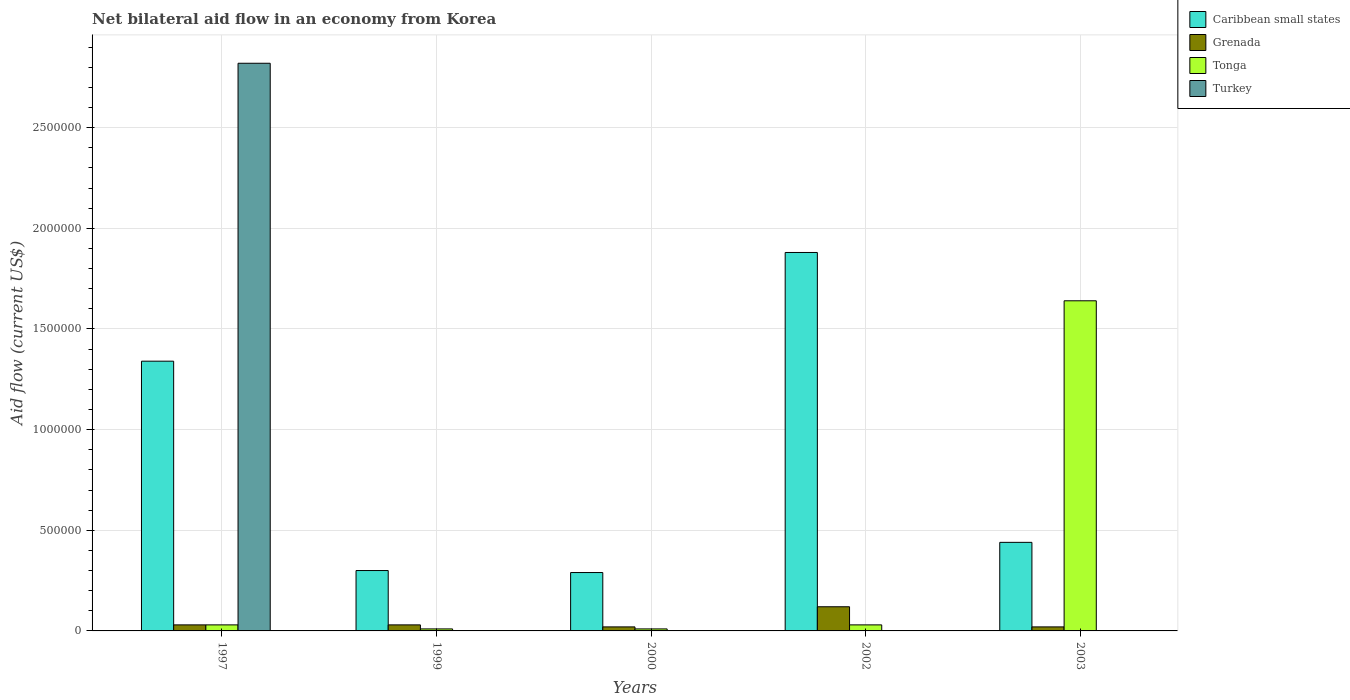How many different coloured bars are there?
Your answer should be very brief. 4. How many groups of bars are there?
Provide a short and direct response. 5. Are the number of bars on each tick of the X-axis equal?
Provide a succinct answer. No. How many bars are there on the 5th tick from the right?
Your answer should be very brief. 4. What is the label of the 1st group of bars from the left?
Give a very brief answer. 1997. In how many cases, is the number of bars for a given year not equal to the number of legend labels?
Offer a terse response. 4. Across all years, what is the minimum net bilateral aid flow in Caribbean small states?
Give a very brief answer. 2.90e+05. In which year was the net bilateral aid flow in Turkey maximum?
Provide a succinct answer. 1997. What is the difference between the net bilateral aid flow in Caribbean small states in 2003 and the net bilateral aid flow in Turkey in 1997?
Your response must be concise. -2.38e+06. What is the average net bilateral aid flow in Turkey per year?
Your response must be concise. 5.64e+05. In the year 2003, what is the difference between the net bilateral aid flow in Grenada and net bilateral aid flow in Tonga?
Your response must be concise. -1.62e+06. In how many years, is the net bilateral aid flow in Turkey greater than 2500000 US$?
Your answer should be compact. 1. What is the ratio of the net bilateral aid flow in Grenada in 1997 to that in 2000?
Ensure brevity in your answer.  1.5. Is the net bilateral aid flow in Tonga in 1999 less than that in 2000?
Provide a succinct answer. No. What is the difference between the highest and the second highest net bilateral aid flow in Grenada?
Offer a terse response. 9.00e+04. What is the difference between the highest and the lowest net bilateral aid flow in Grenada?
Give a very brief answer. 1.00e+05. In how many years, is the net bilateral aid flow in Turkey greater than the average net bilateral aid flow in Turkey taken over all years?
Keep it short and to the point. 1. Is it the case that in every year, the sum of the net bilateral aid flow in Turkey and net bilateral aid flow in Tonga is greater than the sum of net bilateral aid flow in Caribbean small states and net bilateral aid flow in Grenada?
Offer a terse response. No. What is the difference between two consecutive major ticks on the Y-axis?
Ensure brevity in your answer.  5.00e+05. Does the graph contain any zero values?
Offer a terse response. Yes. How many legend labels are there?
Provide a succinct answer. 4. What is the title of the graph?
Offer a very short reply. Net bilateral aid flow in an economy from Korea. What is the label or title of the X-axis?
Your answer should be compact. Years. What is the label or title of the Y-axis?
Provide a short and direct response. Aid flow (current US$). What is the Aid flow (current US$) in Caribbean small states in 1997?
Your answer should be very brief. 1.34e+06. What is the Aid flow (current US$) of Turkey in 1997?
Give a very brief answer. 2.82e+06. What is the Aid flow (current US$) of Caribbean small states in 1999?
Ensure brevity in your answer.  3.00e+05. What is the Aid flow (current US$) in Tonga in 1999?
Offer a very short reply. 10000. What is the Aid flow (current US$) of Caribbean small states in 2000?
Keep it short and to the point. 2.90e+05. What is the Aid flow (current US$) in Turkey in 2000?
Keep it short and to the point. 0. What is the Aid flow (current US$) of Caribbean small states in 2002?
Provide a succinct answer. 1.88e+06. What is the Aid flow (current US$) of Caribbean small states in 2003?
Offer a terse response. 4.40e+05. What is the Aid flow (current US$) in Tonga in 2003?
Your response must be concise. 1.64e+06. What is the Aid flow (current US$) in Turkey in 2003?
Offer a very short reply. 0. Across all years, what is the maximum Aid flow (current US$) of Caribbean small states?
Offer a very short reply. 1.88e+06. Across all years, what is the maximum Aid flow (current US$) of Grenada?
Ensure brevity in your answer.  1.20e+05. Across all years, what is the maximum Aid flow (current US$) in Tonga?
Give a very brief answer. 1.64e+06. Across all years, what is the maximum Aid flow (current US$) in Turkey?
Your answer should be very brief. 2.82e+06. Across all years, what is the minimum Aid flow (current US$) of Turkey?
Your answer should be very brief. 0. What is the total Aid flow (current US$) of Caribbean small states in the graph?
Give a very brief answer. 4.25e+06. What is the total Aid flow (current US$) in Tonga in the graph?
Give a very brief answer. 1.72e+06. What is the total Aid flow (current US$) of Turkey in the graph?
Offer a very short reply. 2.82e+06. What is the difference between the Aid flow (current US$) in Caribbean small states in 1997 and that in 1999?
Ensure brevity in your answer.  1.04e+06. What is the difference between the Aid flow (current US$) in Grenada in 1997 and that in 1999?
Your answer should be very brief. 0. What is the difference between the Aid flow (current US$) in Tonga in 1997 and that in 1999?
Make the answer very short. 2.00e+04. What is the difference between the Aid flow (current US$) in Caribbean small states in 1997 and that in 2000?
Your response must be concise. 1.05e+06. What is the difference between the Aid flow (current US$) in Caribbean small states in 1997 and that in 2002?
Ensure brevity in your answer.  -5.40e+05. What is the difference between the Aid flow (current US$) in Grenada in 1997 and that in 2002?
Offer a terse response. -9.00e+04. What is the difference between the Aid flow (current US$) in Tonga in 1997 and that in 2002?
Provide a succinct answer. 0. What is the difference between the Aid flow (current US$) of Grenada in 1997 and that in 2003?
Provide a succinct answer. 10000. What is the difference between the Aid flow (current US$) in Tonga in 1997 and that in 2003?
Your response must be concise. -1.61e+06. What is the difference between the Aid flow (current US$) of Caribbean small states in 1999 and that in 2000?
Offer a very short reply. 10000. What is the difference between the Aid flow (current US$) in Tonga in 1999 and that in 2000?
Your response must be concise. 0. What is the difference between the Aid flow (current US$) of Caribbean small states in 1999 and that in 2002?
Offer a very short reply. -1.58e+06. What is the difference between the Aid flow (current US$) in Caribbean small states in 1999 and that in 2003?
Ensure brevity in your answer.  -1.40e+05. What is the difference between the Aid flow (current US$) in Tonga in 1999 and that in 2003?
Keep it short and to the point. -1.63e+06. What is the difference between the Aid flow (current US$) of Caribbean small states in 2000 and that in 2002?
Keep it short and to the point. -1.59e+06. What is the difference between the Aid flow (current US$) in Grenada in 2000 and that in 2002?
Ensure brevity in your answer.  -1.00e+05. What is the difference between the Aid flow (current US$) in Tonga in 2000 and that in 2002?
Your answer should be very brief. -2.00e+04. What is the difference between the Aid flow (current US$) of Caribbean small states in 2000 and that in 2003?
Your answer should be very brief. -1.50e+05. What is the difference between the Aid flow (current US$) of Tonga in 2000 and that in 2003?
Provide a succinct answer. -1.63e+06. What is the difference between the Aid flow (current US$) in Caribbean small states in 2002 and that in 2003?
Make the answer very short. 1.44e+06. What is the difference between the Aid flow (current US$) in Tonga in 2002 and that in 2003?
Your answer should be very brief. -1.61e+06. What is the difference between the Aid flow (current US$) of Caribbean small states in 1997 and the Aid flow (current US$) of Grenada in 1999?
Your answer should be very brief. 1.31e+06. What is the difference between the Aid flow (current US$) in Caribbean small states in 1997 and the Aid flow (current US$) in Tonga in 1999?
Provide a succinct answer. 1.33e+06. What is the difference between the Aid flow (current US$) in Grenada in 1997 and the Aid flow (current US$) in Tonga in 1999?
Offer a very short reply. 2.00e+04. What is the difference between the Aid flow (current US$) in Caribbean small states in 1997 and the Aid flow (current US$) in Grenada in 2000?
Your answer should be compact. 1.32e+06. What is the difference between the Aid flow (current US$) of Caribbean small states in 1997 and the Aid flow (current US$) of Tonga in 2000?
Your answer should be compact. 1.33e+06. What is the difference between the Aid flow (current US$) of Caribbean small states in 1997 and the Aid flow (current US$) of Grenada in 2002?
Make the answer very short. 1.22e+06. What is the difference between the Aid flow (current US$) of Caribbean small states in 1997 and the Aid flow (current US$) of Tonga in 2002?
Keep it short and to the point. 1.31e+06. What is the difference between the Aid flow (current US$) of Grenada in 1997 and the Aid flow (current US$) of Tonga in 2002?
Your answer should be compact. 0. What is the difference between the Aid flow (current US$) of Caribbean small states in 1997 and the Aid flow (current US$) of Grenada in 2003?
Offer a terse response. 1.32e+06. What is the difference between the Aid flow (current US$) in Caribbean small states in 1997 and the Aid flow (current US$) in Tonga in 2003?
Your answer should be compact. -3.00e+05. What is the difference between the Aid flow (current US$) in Grenada in 1997 and the Aid flow (current US$) in Tonga in 2003?
Provide a short and direct response. -1.61e+06. What is the difference between the Aid flow (current US$) in Caribbean small states in 1999 and the Aid flow (current US$) in Tonga in 2000?
Offer a terse response. 2.90e+05. What is the difference between the Aid flow (current US$) in Grenada in 1999 and the Aid flow (current US$) in Tonga in 2000?
Keep it short and to the point. 2.00e+04. What is the difference between the Aid flow (current US$) in Caribbean small states in 1999 and the Aid flow (current US$) in Grenada in 2002?
Offer a terse response. 1.80e+05. What is the difference between the Aid flow (current US$) in Caribbean small states in 1999 and the Aid flow (current US$) in Tonga in 2002?
Ensure brevity in your answer.  2.70e+05. What is the difference between the Aid flow (current US$) of Grenada in 1999 and the Aid flow (current US$) of Tonga in 2002?
Make the answer very short. 0. What is the difference between the Aid flow (current US$) of Caribbean small states in 1999 and the Aid flow (current US$) of Tonga in 2003?
Your response must be concise. -1.34e+06. What is the difference between the Aid flow (current US$) of Grenada in 1999 and the Aid flow (current US$) of Tonga in 2003?
Offer a very short reply. -1.61e+06. What is the difference between the Aid flow (current US$) of Caribbean small states in 2000 and the Aid flow (current US$) of Tonga in 2002?
Provide a succinct answer. 2.60e+05. What is the difference between the Aid flow (current US$) of Grenada in 2000 and the Aid flow (current US$) of Tonga in 2002?
Your response must be concise. -10000. What is the difference between the Aid flow (current US$) in Caribbean small states in 2000 and the Aid flow (current US$) in Tonga in 2003?
Give a very brief answer. -1.35e+06. What is the difference between the Aid flow (current US$) of Grenada in 2000 and the Aid flow (current US$) of Tonga in 2003?
Provide a succinct answer. -1.62e+06. What is the difference between the Aid flow (current US$) in Caribbean small states in 2002 and the Aid flow (current US$) in Grenada in 2003?
Provide a succinct answer. 1.86e+06. What is the difference between the Aid flow (current US$) in Grenada in 2002 and the Aid flow (current US$) in Tonga in 2003?
Make the answer very short. -1.52e+06. What is the average Aid flow (current US$) of Caribbean small states per year?
Your answer should be compact. 8.50e+05. What is the average Aid flow (current US$) in Grenada per year?
Give a very brief answer. 4.40e+04. What is the average Aid flow (current US$) in Tonga per year?
Your answer should be compact. 3.44e+05. What is the average Aid flow (current US$) of Turkey per year?
Keep it short and to the point. 5.64e+05. In the year 1997, what is the difference between the Aid flow (current US$) of Caribbean small states and Aid flow (current US$) of Grenada?
Your response must be concise. 1.31e+06. In the year 1997, what is the difference between the Aid flow (current US$) in Caribbean small states and Aid flow (current US$) in Tonga?
Make the answer very short. 1.31e+06. In the year 1997, what is the difference between the Aid flow (current US$) in Caribbean small states and Aid flow (current US$) in Turkey?
Ensure brevity in your answer.  -1.48e+06. In the year 1997, what is the difference between the Aid flow (current US$) of Grenada and Aid flow (current US$) of Turkey?
Make the answer very short. -2.79e+06. In the year 1997, what is the difference between the Aid flow (current US$) of Tonga and Aid flow (current US$) of Turkey?
Ensure brevity in your answer.  -2.79e+06. In the year 1999, what is the difference between the Aid flow (current US$) of Caribbean small states and Aid flow (current US$) of Grenada?
Give a very brief answer. 2.70e+05. In the year 1999, what is the difference between the Aid flow (current US$) in Grenada and Aid flow (current US$) in Tonga?
Make the answer very short. 2.00e+04. In the year 2000, what is the difference between the Aid flow (current US$) of Caribbean small states and Aid flow (current US$) of Grenada?
Ensure brevity in your answer.  2.70e+05. In the year 2002, what is the difference between the Aid flow (current US$) of Caribbean small states and Aid flow (current US$) of Grenada?
Give a very brief answer. 1.76e+06. In the year 2002, what is the difference between the Aid flow (current US$) of Caribbean small states and Aid flow (current US$) of Tonga?
Keep it short and to the point. 1.85e+06. In the year 2003, what is the difference between the Aid flow (current US$) in Caribbean small states and Aid flow (current US$) in Tonga?
Give a very brief answer. -1.20e+06. In the year 2003, what is the difference between the Aid flow (current US$) of Grenada and Aid flow (current US$) of Tonga?
Provide a succinct answer. -1.62e+06. What is the ratio of the Aid flow (current US$) of Caribbean small states in 1997 to that in 1999?
Your response must be concise. 4.47. What is the ratio of the Aid flow (current US$) of Grenada in 1997 to that in 1999?
Keep it short and to the point. 1. What is the ratio of the Aid flow (current US$) in Caribbean small states in 1997 to that in 2000?
Offer a very short reply. 4.62. What is the ratio of the Aid flow (current US$) of Grenada in 1997 to that in 2000?
Your answer should be very brief. 1.5. What is the ratio of the Aid flow (current US$) of Caribbean small states in 1997 to that in 2002?
Offer a terse response. 0.71. What is the ratio of the Aid flow (current US$) of Grenada in 1997 to that in 2002?
Provide a short and direct response. 0.25. What is the ratio of the Aid flow (current US$) of Tonga in 1997 to that in 2002?
Make the answer very short. 1. What is the ratio of the Aid flow (current US$) of Caribbean small states in 1997 to that in 2003?
Give a very brief answer. 3.05. What is the ratio of the Aid flow (current US$) in Grenada in 1997 to that in 2003?
Keep it short and to the point. 1.5. What is the ratio of the Aid flow (current US$) in Tonga in 1997 to that in 2003?
Ensure brevity in your answer.  0.02. What is the ratio of the Aid flow (current US$) of Caribbean small states in 1999 to that in 2000?
Give a very brief answer. 1.03. What is the ratio of the Aid flow (current US$) in Tonga in 1999 to that in 2000?
Your answer should be very brief. 1. What is the ratio of the Aid flow (current US$) in Caribbean small states in 1999 to that in 2002?
Give a very brief answer. 0.16. What is the ratio of the Aid flow (current US$) of Tonga in 1999 to that in 2002?
Make the answer very short. 0.33. What is the ratio of the Aid flow (current US$) of Caribbean small states in 1999 to that in 2003?
Your response must be concise. 0.68. What is the ratio of the Aid flow (current US$) in Grenada in 1999 to that in 2003?
Provide a succinct answer. 1.5. What is the ratio of the Aid flow (current US$) of Tonga in 1999 to that in 2003?
Provide a short and direct response. 0.01. What is the ratio of the Aid flow (current US$) in Caribbean small states in 2000 to that in 2002?
Provide a short and direct response. 0.15. What is the ratio of the Aid flow (current US$) of Tonga in 2000 to that in 2002?
Give a very brief answer. 0.33. What is the ratio of the Aid flow (current US$) in Caribbean small states in 2000 to that in 2003?
Keep it short and to the point. 0.66. What is the ratio of the Aid flow (current US$) of Tonga in 2000 to that in 2003?
Your response must be concise. 0.01. What is the ratio of the Aid flow (current US$) in Caribbean small states in 2002 to that in 2003?
Offer a terse response. 4.27. What is the ratio of the Aid flow (current US$) in Tonga in 2002 to that in 2003?
Offer a terse response. 0.02. What is the difference between the highest and the second highest Aid flow (current US$) of Caribbean small states?
Provide a succinct answer. 5.40e+05. What is the difference between the highest and the second highest Aid flow (current US$) in Grenada?
Provide a succinct answer. 9.00e+04. What is the difference between the highest and the second highest Aid flow (current US$) of Tonga?
Your answer should be compact. 1.61e+06. What is the difference between the highest and the lowest Aid flow (current US$) in Caribbean small states?
Your response must be concise. 1.59e+06. What is the difference between the highest and the lowest Aid flow (current US$) of Tonga?
Provide a succinct answer. 1.63e+06. What is the difference between the highest and the lowest Aid flow (current US$) in Turkey?
Offer a very short reply. 2.82e+06. 